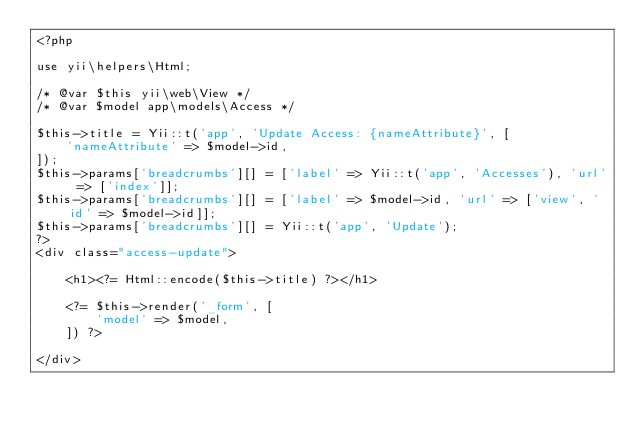Convert code to text. <code><loc_0><loc_0><loc_500><loc_500><_PHP_><?php

use yii\helpers\Html;

/* @var $this yii\web\View */
/* @var $model app\models\Access */

$this->title = Yii::t('app', 'Update Access: {nameAttribute}', [
    'nameAttribute' => $model->id,
]);
$this->params['breadcrumbs'][] = ['label' => Yii::t('app', 'Accesses'), 'url' => ['index']];
$this->params['breadcrumbs'][] = ['label' => $model->id, 'url' => ['view', 'id' => $model->id]];
$this->params['breadcrumbs'][] = Yii::t('app', 'Update');
?>
<div class="access-update">

    <h1><?= Html::encode($this->title) ?></h1>

    <?= $this->render('_form', [
        'model' => $model,
    ]) ?>

</div>
</code> 